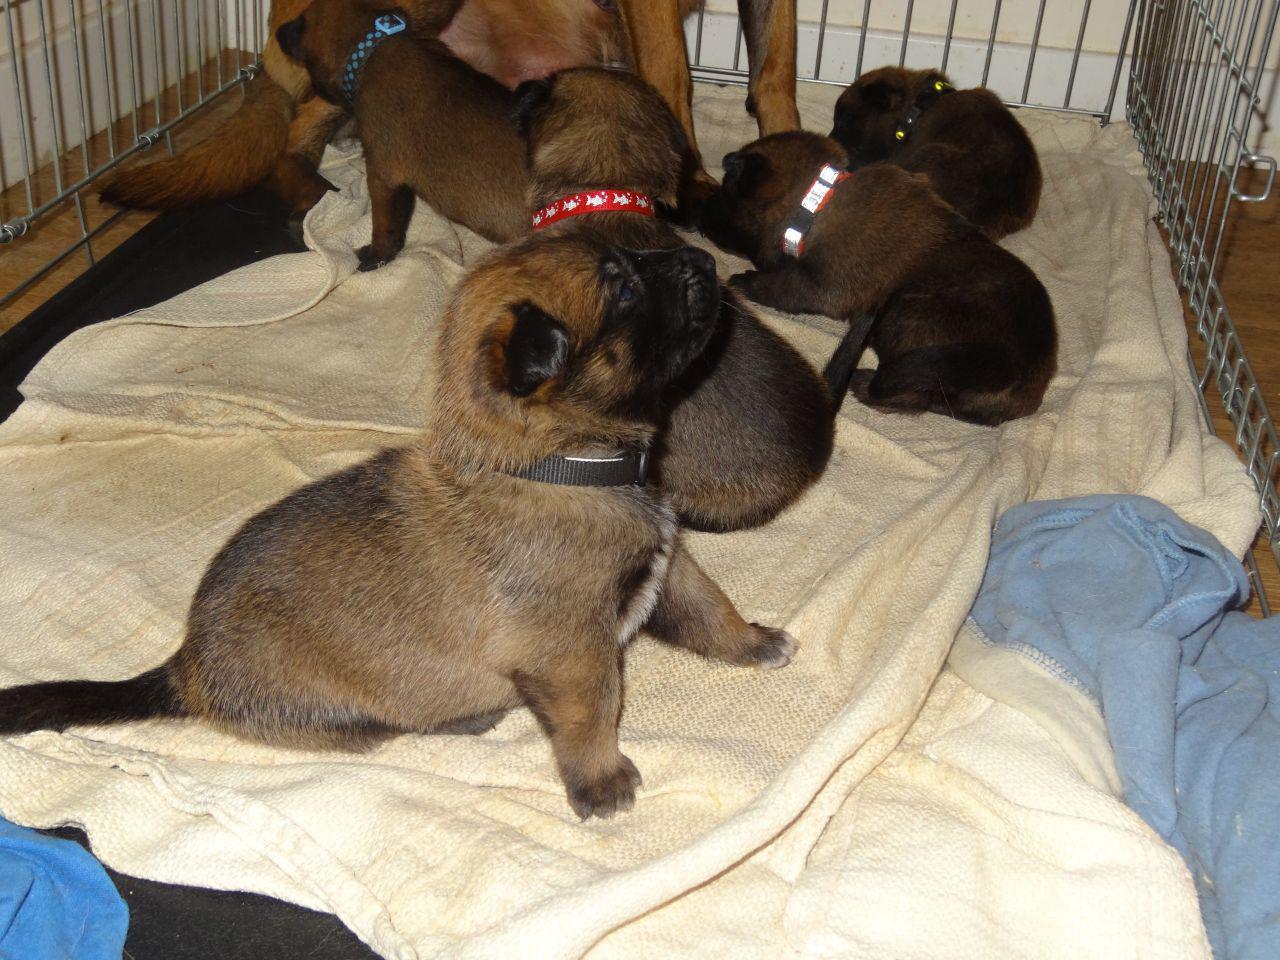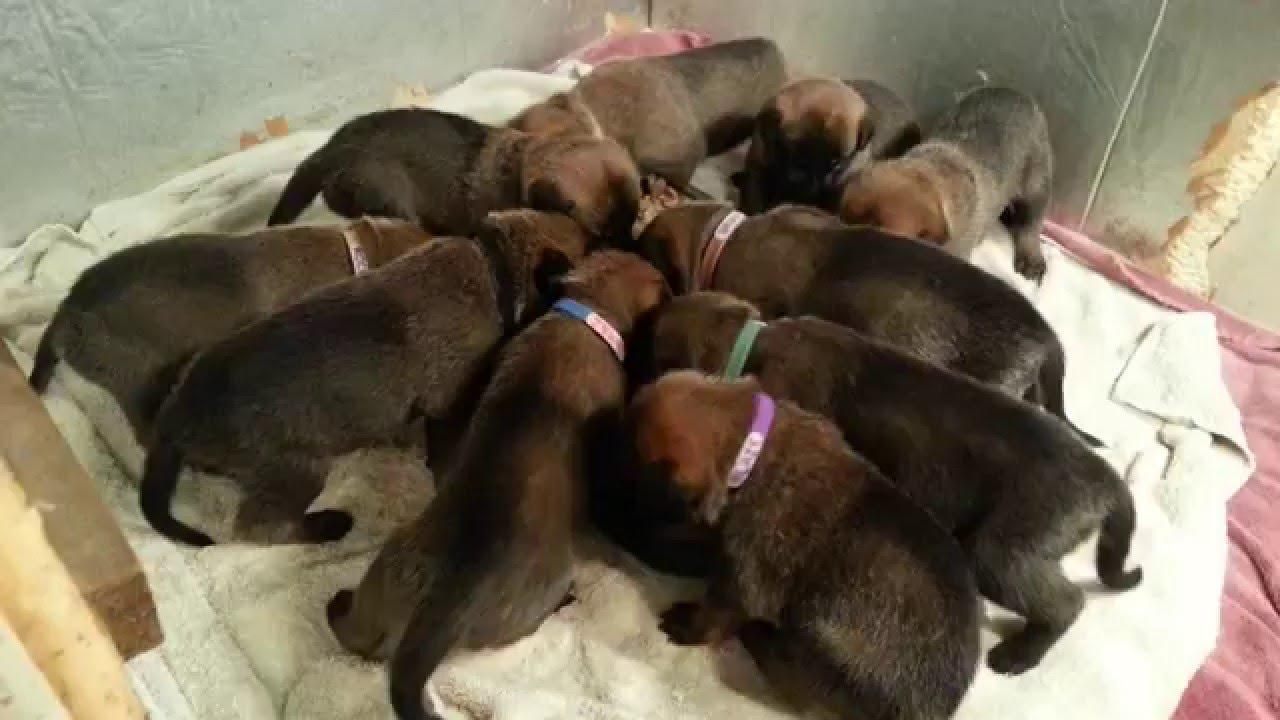The first image is the image on the left, the second image is the image on the right. Evaluate the accuracy of this statement regarding the images: "An image shows puppies in collars on a blanket, with their heads aimed toward the middle of the group.". Is it true? Answer yes or no. Yes. The first image is the image on the left, the second image is the image on the right. For the images displayed, is the sentence "There's no more than five dogs in the right image." factually correct? Answer yes or no. No. 